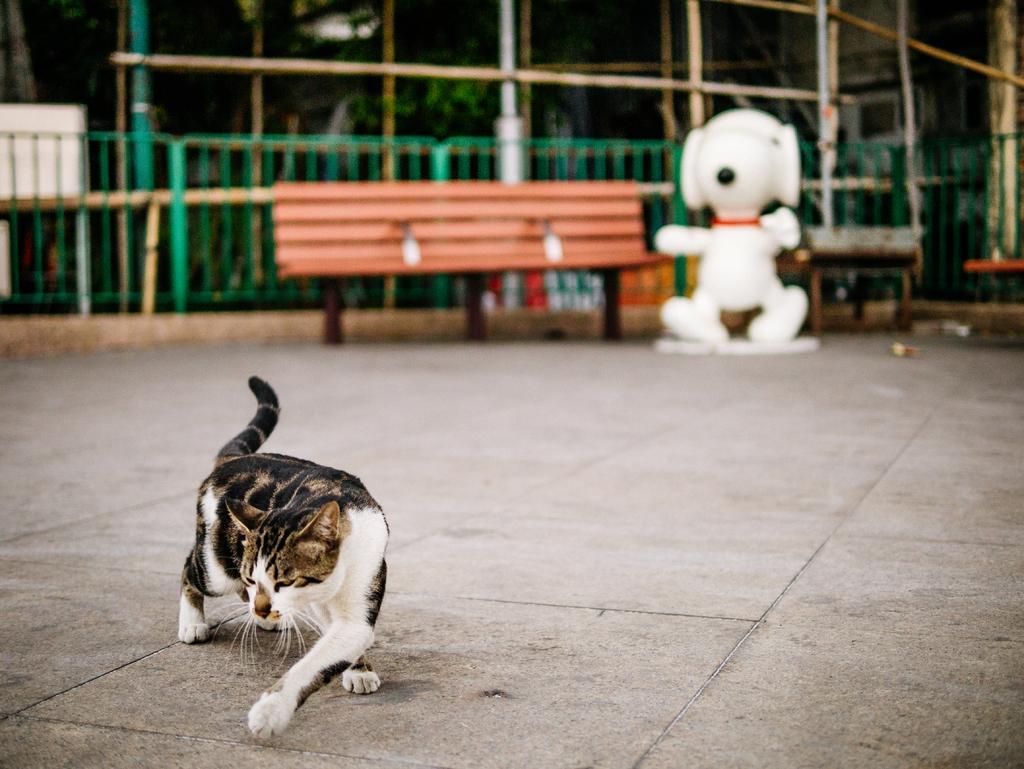Can you describe this image briefly? This picture describes about a cat in the background we can see a bench, a toy, metal fence, and couple of trees. 